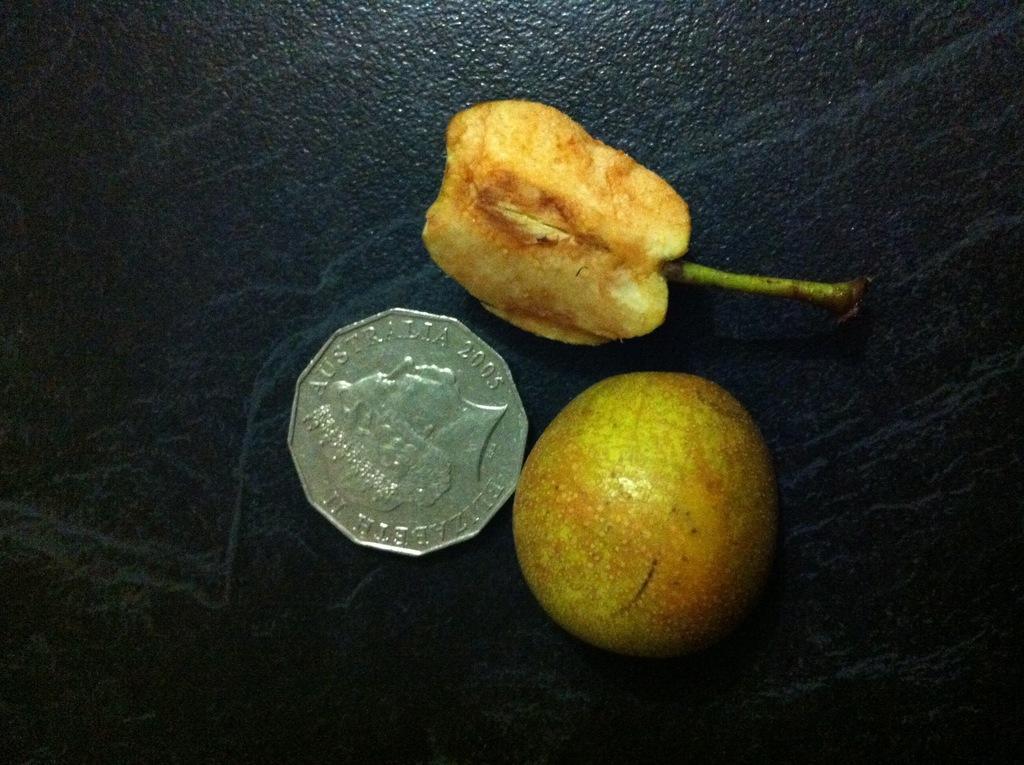Describe this image in one or two sentences. In this image we can see the fruits, beside there is the coin on the black surface. 